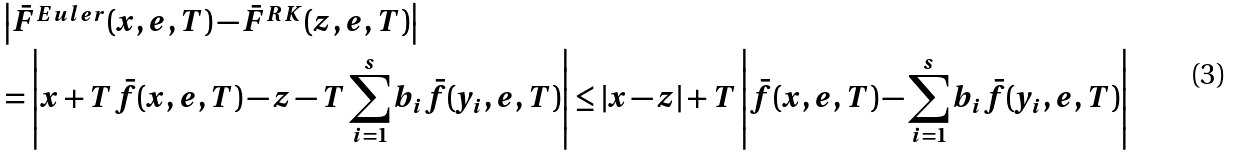Convert formula to latex. <formula><loc_0><loc_0><loc_500><loc_500>& \left | \bar { F } ^ { E u l e r } ( x , e , T ) - \bar { F } ^ { R K } ( z , e , T ) \right | \\ & = \left | x + T \bar { f } ( x , e , T ) - z - T \sum _ { i = 1 } ^ { s } b _ { i } \bar { f } ( y _ { i } , e , T ) \right | \leq | x - z | + T \left | \bar { f } ( x , e , T ) - \sum _ { i = 1 } ^ { s } b _ { i } \bar { f } ( y _ { i } , e , T ) \right |</formula> 